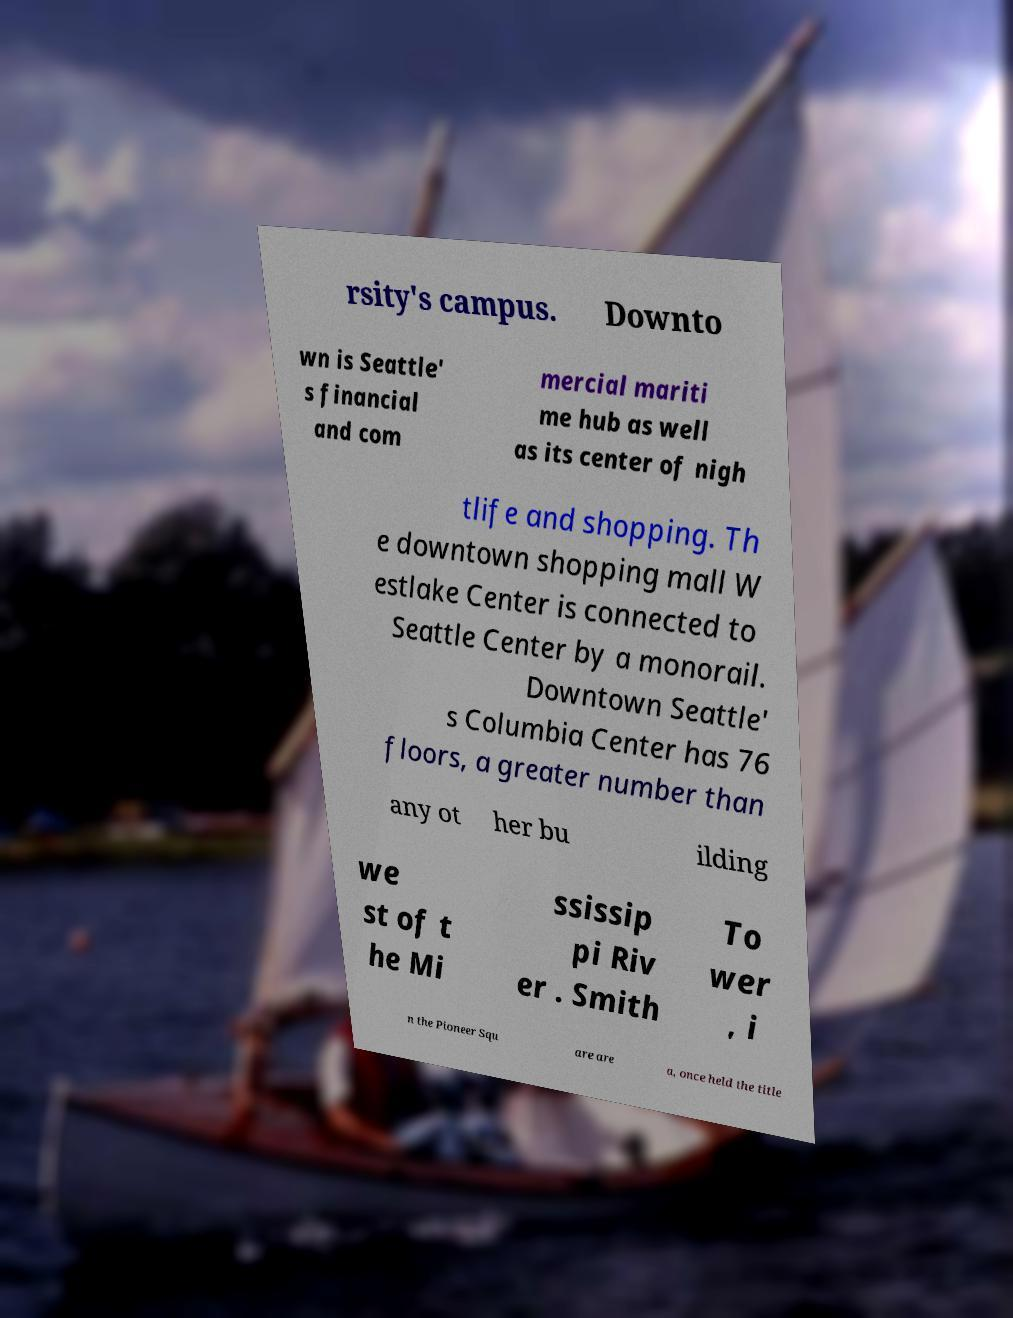Can you read and provide the text displayed in the image?This photo seems to have some interesting text. Can you extract and type it out for me? rsity's campus. Downto wn is Seattle' s financial and com mercial mariti me hub as well as its center of nigh tlife and shopping. Th e downtown shopping mall W estlake Center is connected to Seattle Center by a monorail. Downtown Seattle' s Columbia Center has 76 floors, a greater number than any ot her bu ilding we st of t he Mi ssissip pi Riv er . Smith To wer , i n the Pioneer Squ are are a, once held the title 